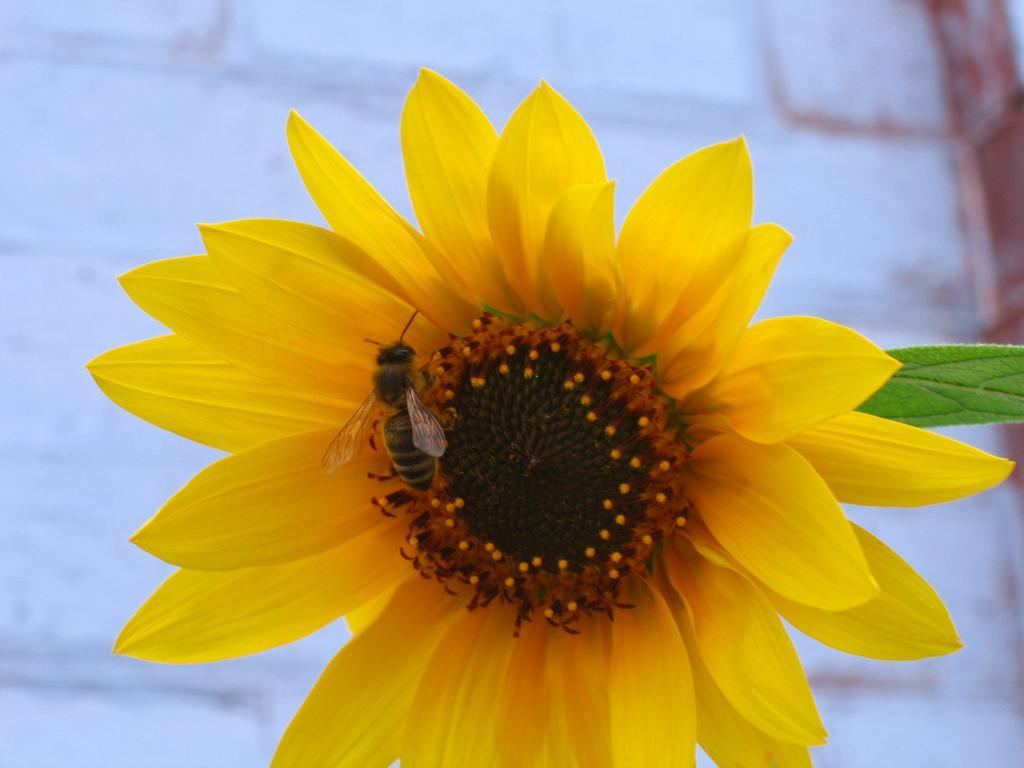What type of plant is featured in the image? There is a sunflower in the image. What is on the sunflower? A bee is on the sunflower. What can be seen on the right side of the image? There is a leaf on the right side of the image. What is visible in the background of the image? There is a wall in the background of the image. What type of amusement can be seen in the image? There is no amusement present in the image; it features a sunflower with a bee on it, a leaf, and a wall in the background. 